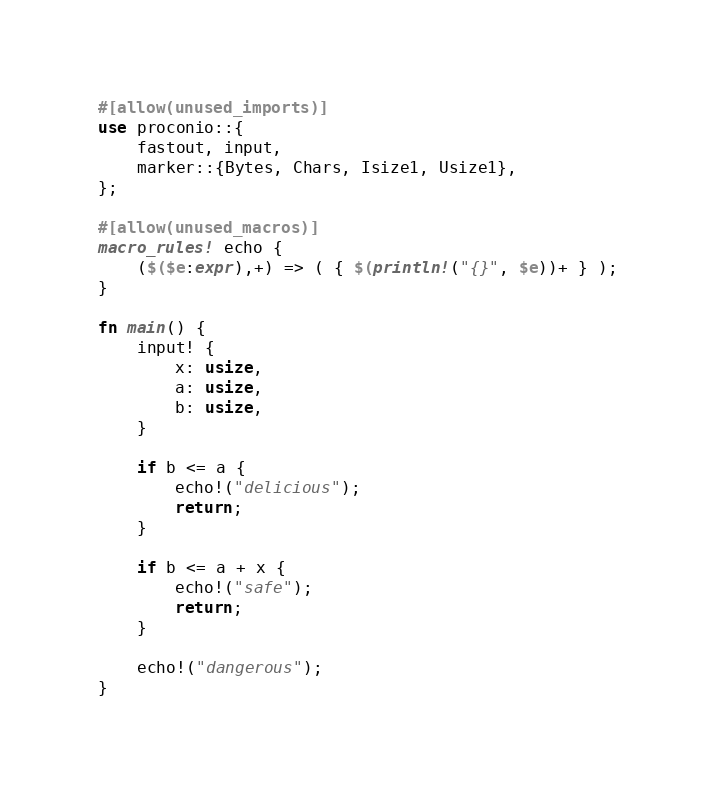Convert code to text. <code><loc_0><loc_0><loc_500><loc_500><_Rust_>#[allow(unused_imports)]
use proconio::{
    fastout, input,
    marker::{Bytes, Chars, Isize1, Usize1},
};

#[allow(unused_macros)]
macro_rules! echo {
    ($($e:expr),+) => ( { $(println!("{}", $e))+ } );
}

fn main() {
    input! {
        x: usize,
        a: usize,
        b: usize,
    }

    if b <= a {
        echo!("delicious");
        return;
    }

    if b <= a + x {
        echo!("safe");
        return;
    }

    echo!("dangerous");
}
</code> 